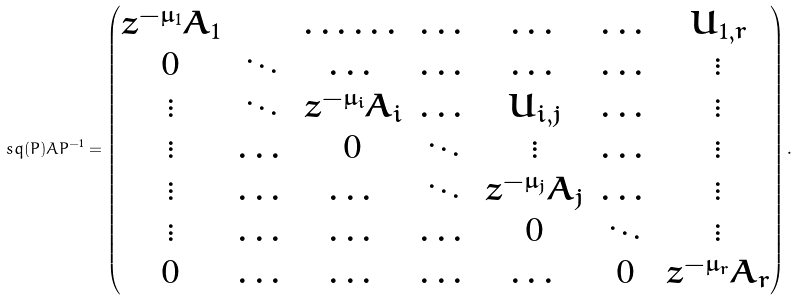Convert formula to latex. <formula><loc_0><loc_0><loc_500><loc_500>\ s q ( P ) A P ^ { - 1 } = \begin{pmatrix} z ^ { - { \mu _ { 1 } } } A _ { 1 } & & \dots \dots & \dots & \dots & \dots & U _ { 1 , r } \\ 0 & \ddots & \dots & \dots & \dots & \dots & \vdots \\ \vdots & \ddots & z ^ { - \mu _ { i } } A _ { i } & \dots & U _ { i , j } & \dots & \vdots \\ \vdots & \dots & 0 & \ddots & \vdots & \dots & \vdots \\ \vdots & \dots & \dots & \ddots & z ^ { - \mu _ { j } } A _ { j } & \dots & \vdots \\ \vdots & \dots & \dots & \dots & 0 & \ddots & \vdots \\ 0 & \dots & \dots & \dots & \dots & 0 & z ^ { - \mu _ { r } } A _ { r } \end{pmatrix} .</formula> 